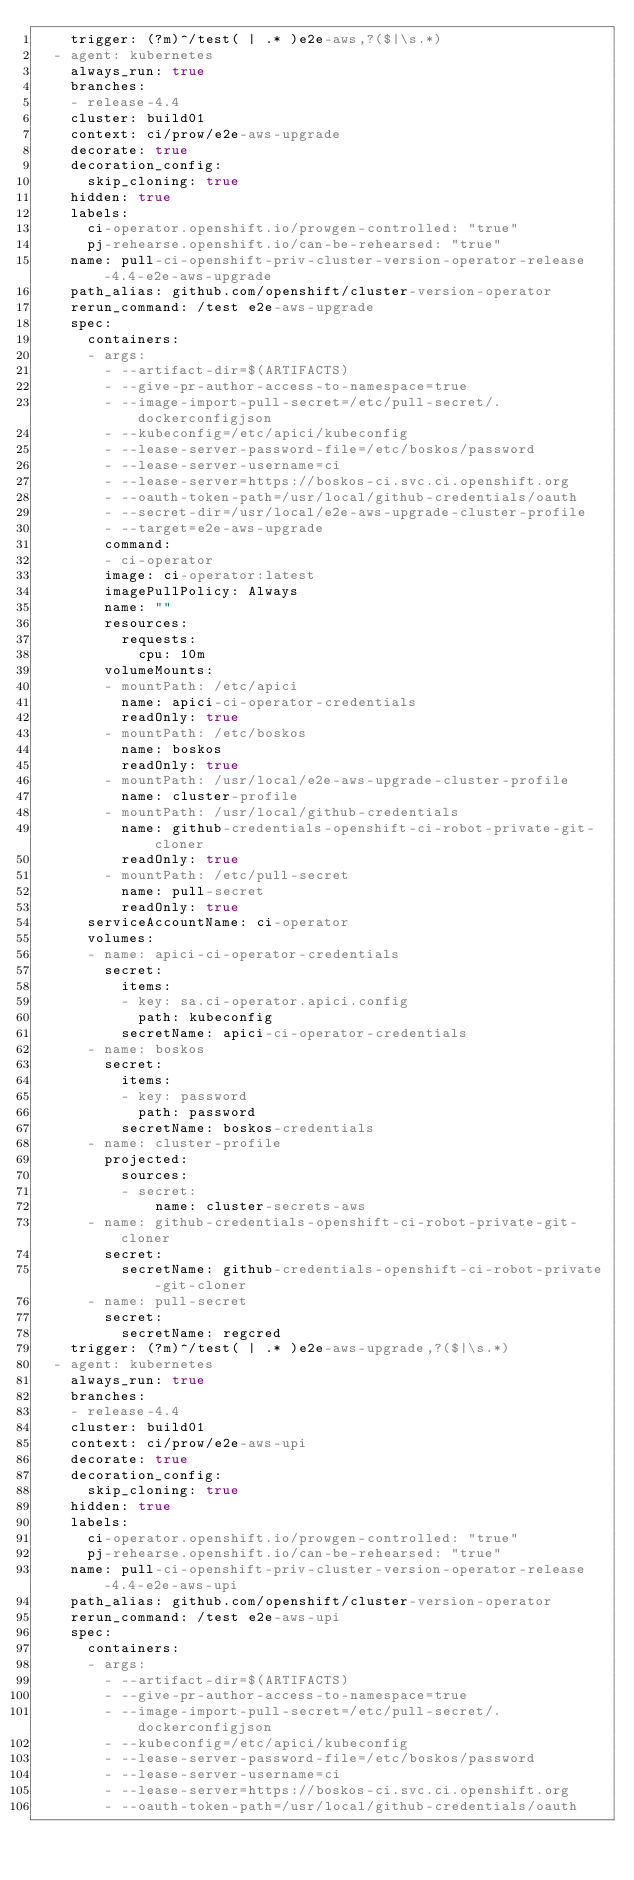<code> <loc_0><loc_0><loc_500><loc_500><_YAML_>    trigger: (?m)^/test( | .* )e2e-aws,?($|\s.*)
  - agent: kubernetes
    always_run: true
    branches:
    - release-4.4
    cluster: build01
    context: ci/prow/e2e-aws-upgrade
    decorate: true
    decoration_config:
      skip_cloning: true
    hidden: true
    labels:
      ci-operator.openshift.io/prowgen-controlled: "true"
      pj-rehearse.openshift.io/can-be-rehearsed: "true"
    name: pull-ci-openshift-priv-cluster-version-operator-release-4.4-e2e-aws-upgrade
    path_alias: github.com/openshift/cluster-version-operator
    rerun_command: /test e2e-aws-upgrade
    spec:
      containers:
      - args:
        - --artifact-dir=$(ARTIFACTS)
        - --give-pr-author-access-to-namespace=true
        - --image-import-pull-secret=/etc/pull-secret/.dockerconfigjson
        - --kubeconfig=/etc/apici/kubeconfig
        - --lease-server-password-file=/etc/boskos/password
        - --lease-server-username=ci
        - --lease-server=https://boskos-ci.svc.ci.openshift.org
        - --oauth-token-path=/usr/local/github-credentials/oauth
        - --secret-dir=/usr/local/e2e-aws-upgrade-cluster-profile
        - --target=e2e-aws-upgrade
        command:
        - ci-operator
        image: ci-operator:latest
        imagePullPolicy: Always
        name: ""
        resources:
          requests:
            cpu: 10m
        volumeMounts:
        - mountPath: /etc/apici
          name: apici-ci-operator-credentials
          readOnly: true
        - mountPath: /etc/boskos
          name: boskos
          readOnly: true
        - mountPath: /usr/local/e2e-aws-upgrade-cluster-profile
          name: cluster-profile
        - mountPath: /usr/local/github-credentials
          name: github-credentials-openshift-ci-robot-private-git-cloner
          readOnly: true
        - mountPath: /etc/pull-secret
          name: pull-secret
          readOnly: true
      serviceAccountName: ci-operator
      volumes:
      - name: apici-ci-operator-credentials
        secret:
          items:
          - key: sa.ci-operator.apici.config
            path: kubeconfig
          secretName: apici-ci-operator-credentials
      - name: boskos
        secret:
          items:
          - key: password
            path: password
          secretName: boskos-credentials
      - name: cluster-profile
        projected:
          sources:
          - secret:
              name: cluster-secrets-aws
      - name: github-credentials-openshift-ci-robot-private-git-cloner
        secret:
          secretName: github-credentials-openshift-ci-robot-private-git-cloner
      - name: pull-secret
        secret:
          secretName: regcred
    trigger: (?m)^/test( | .* )e2e-aws-upgrade,?($|\s.*)
  - agent: kubernetes
    always_run: true
    branches:
    - release-4.4
    cluster: build01
    context: ci/prow/e2e-aws-upi
    decorate: true
    decoration_config:
      skip_cloning: true
    hidden: true
    labels:
      ci-operator.openshift.io/prowgen-controlled: "true"
      pj-rehearse.openshift.io/can-be-rehearsed: "true"
    name: pull-ci-openshift-priv-cluster-version-operator-release-4.4-e2e-aws-upi
    path_alias: github.com/openshift/cluster-version-operator
    rerun_command: /test e2e-aws-upi
    spec:
      containers:
      - args:
        - --artifact-dir=$(ARTIFACTS)
        - --give-pr-author-access-to-namespace=true
        - --image-import-pull-secret=/etc/pull-secret/.dockerconfigjson
        - --kubeconfig=/etc/apici/kubeconfig
        - --lease-server-password-file=/etc/boskos/password
        - --lease-server-username=ci
        - --lease-server=https://boskos-ci.svc.ci.openshift.org
        - --oauth-token-path=/usr/local/github-credentials/oauth</code> 